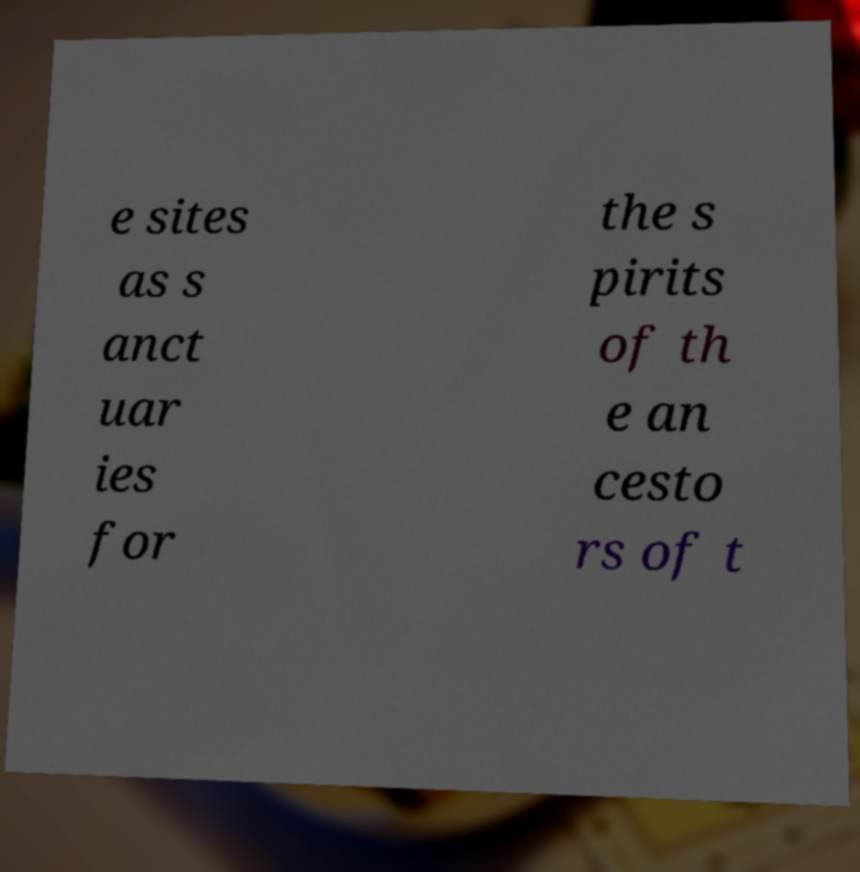Could you extract and type out the text from this image? e sites as s anct uar ies for the s pirits of th e an cesto rs of t 